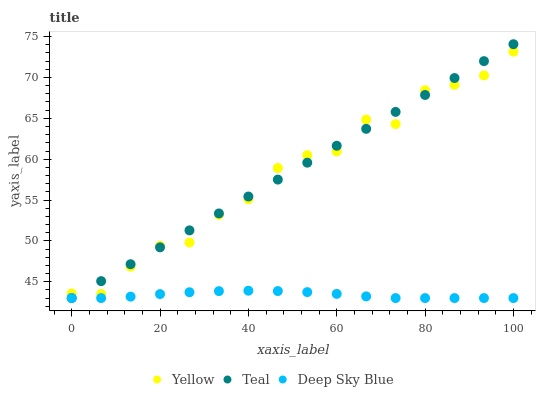Does Deep Sky Blue have the minimum area under the curve?
Answer yes or no. Yes. Does Teal have the maximum area under the curve?
Answer yes or no. Yes. Does Yellow have the minimum area under the curve?
Answer yes or no. No. Does Yellow have the maximum area under the curve?
Answer yes or no. No. Is Teal the smoothest?
Answer yes or no. Yes. Is Yellow the roughest?
Answer yes or no. Yes. Is Yellow the smoothest?
Answer yes or no. No. Is Teal the roughest?
Answer yes or no. No. Does Deep Sky Blue have the lowest value?
Answer yes or no. Yes. Does Yellow have the lowest value?
Answer yes or no. No. Does Teal have the highest value?
Answer yes or no. Yes. Does Yellow have the highest value?
Answer yes or no. No. Is Deep Sky Blue less than Yellow?
Answer yes or no. Yes. Is Yellow greater than Deep Sky Blue?
Answer yes or no. Yes. Does Teal intersect Yellow?
Answer yes or no. Yes. Is Teal less than Yellow?
Answer yes or no. No. Is Teal greater than Yellow?
Answer yes or no. No. Does Deep Sky Blue intersect Yellow?
Answer yes or no. No. 